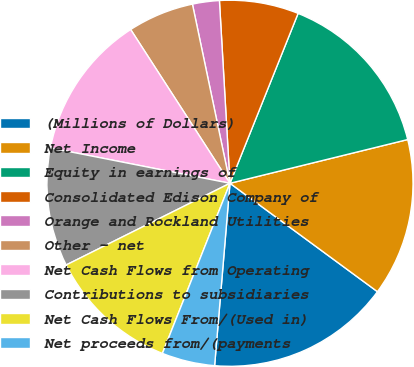Convert chart. <chart><loc_0><loc_0><loc_500><loc_500><pie_chart><fcel>(Millions of Dollars)<fcel>Net Income<fcel>Equity in earnings of<fcel>Consolidated Edison Company of<fcel>Orange and Rockland Utilities<fcel>Other - net<fcel>Net Cash Flows from Operating<fcel>Contributions to subsidiaries<fcel>Net Cash Flows From/(Used in)<fcel>Net proceeds from/(payments<nl><fcel>16.25%<fcel>13.93%<fcel>15.09%<fcel>6.99%<fcel>2.37%<fcel>5.84%<fcel>12.78%<fcel>10.46%<fcel>11.62%<fcel>4.68%<nl></chart> 